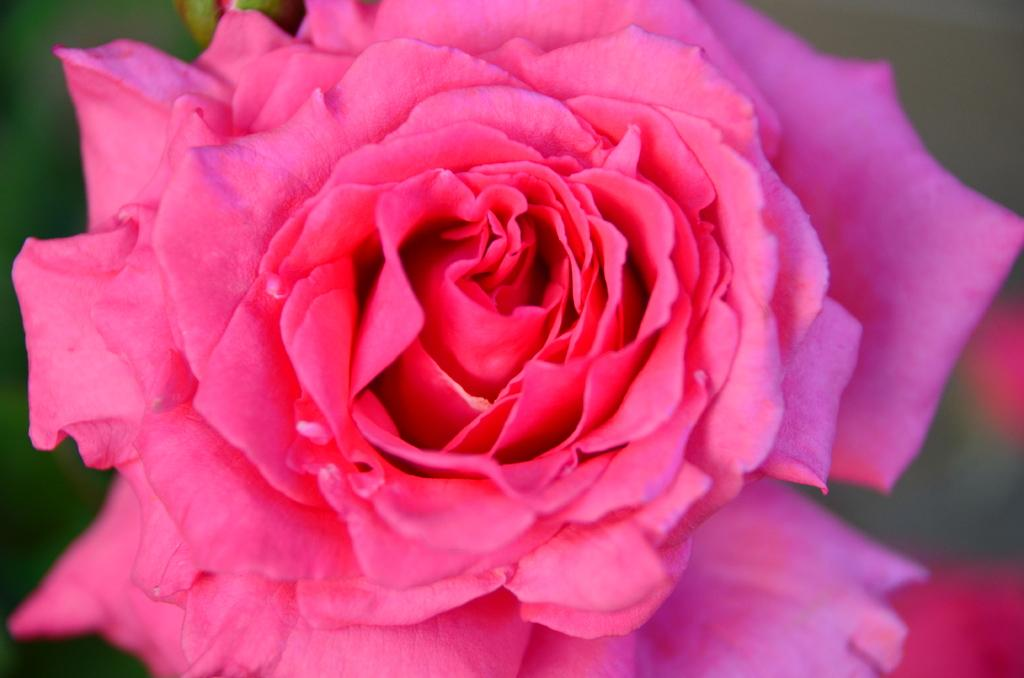What type of flower is in the image? There is a rose in the image. What color is the rose? The rose is pink in color. Where is the bedroom located in the image? A: There is no bedroom present in the image; it only features a pink rose. What type of class is being taught in the image? There is no class or teaching activity depicted in the image; it only features a pink rose. 